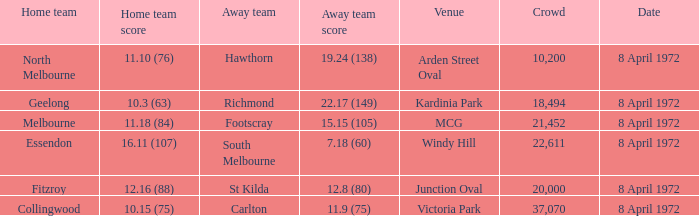Which Away team score has a Venue of kardinia park? 22.17 (149). 